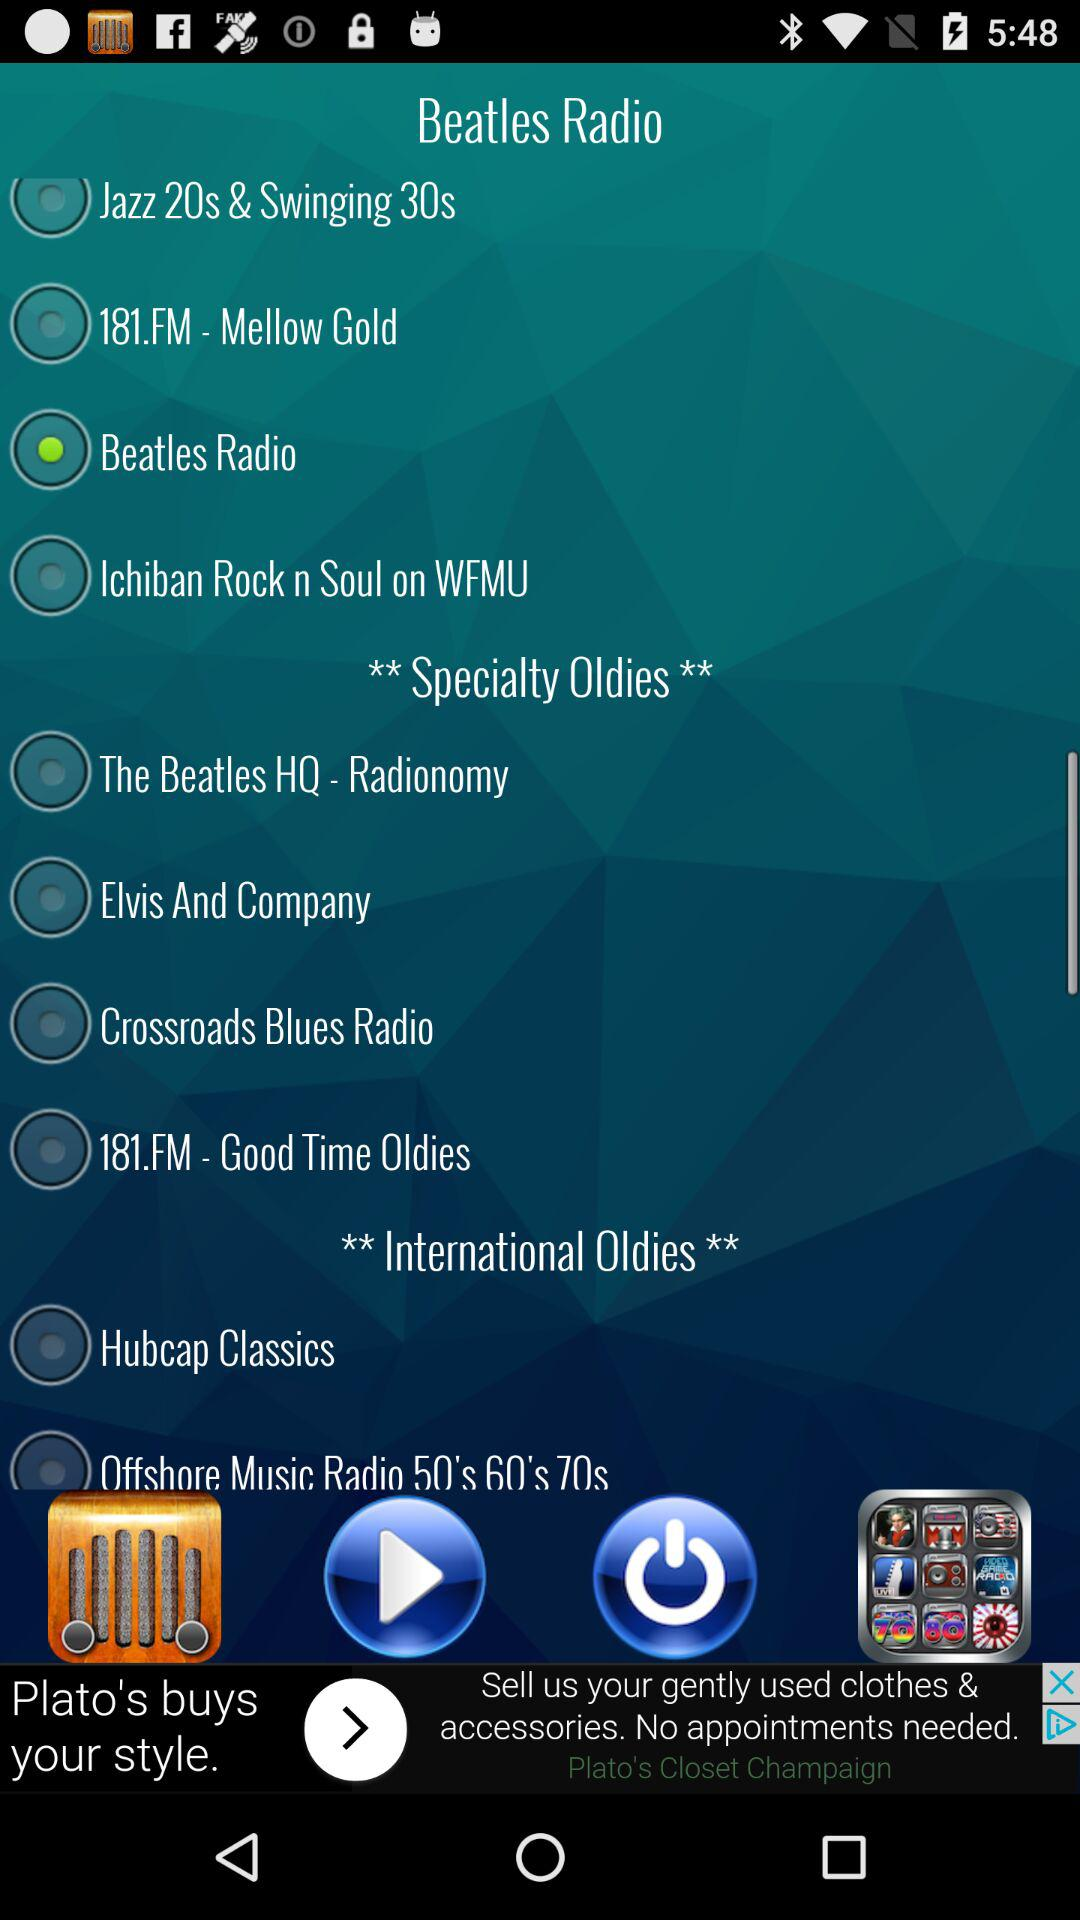Is "181.FM - Mellow Gold" selected or not? "181.FM - Mellow Gold" is not selected. 